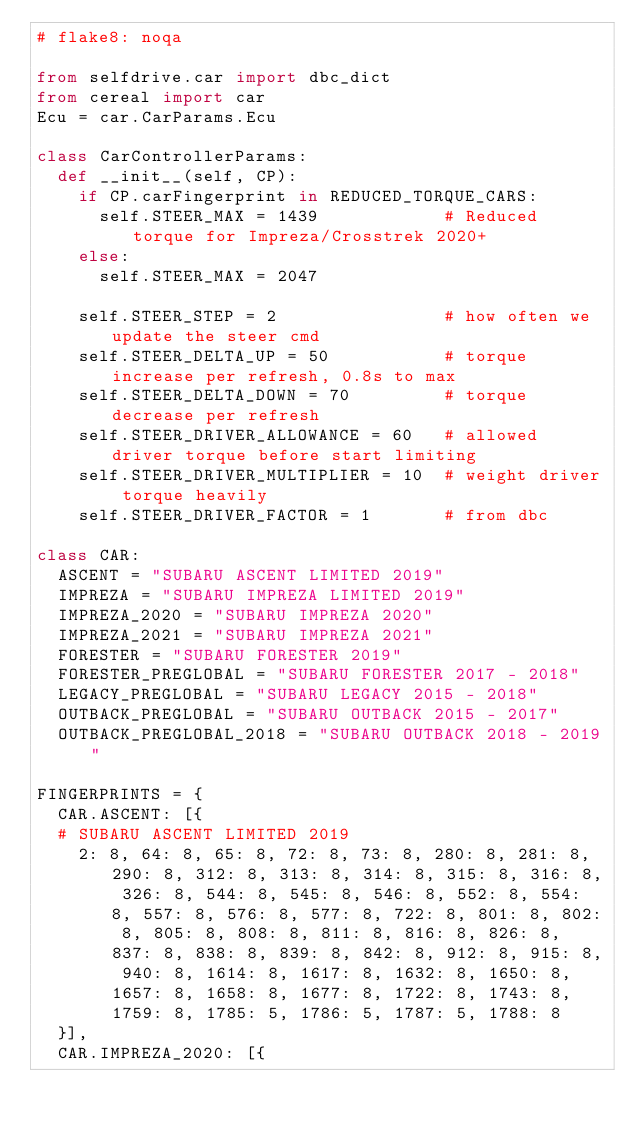Convert code to text. <code><loc_0><loc_0><loc_500><loc_500><_Python_># flake8: noqa

from selfdrive.car import dbc_dict
from cereal import car
Ecu = car.CarParams.Ecu

class CarControllerParams:
  def __init__(self, CP):
    if CP.carFingerprint in REDUCED_TORQUE_CARS:
      self.STEER_MAX = 1439            # Reduced torque for Impreza/Crosstrek 2020+
    else:
      self.STEER_MAX = 2047

    self.STEER_STEP = 2                # how often we update the steer cmd
    self.STEER_DELTA_UP = 50           # torque increase per refresh, 0.8s to max
    self.STEER_DELTA_DOWN = 70         # torque decrease per refresh
    self.STEER_DRIVER_ALLOWANCE = 60   # allowed driver torque before start limiting
    self.STEER_DRIVER_MULTIPLIER = 10  # weight driver torque heavily
    self.STEER_DRIVER_FACTOR = 1       # from dbc

class CAR:
  ASCENT = "SUBARU ASCENT LIMITED 2019"
  IMPREZA = "SUBARU IMPREZA LIMITED 2019"
  IMPREZA_2020 = "SUBARU IMPREZA 2020"
  IMPREZA_2021 = "SUBARU IMPREZA 2021"
  FORESTER = "SUBARU FORESTER 2019"
  FORESTER_PREGLOBAL = "SUBARU FORESTER 2017 - 2018"
  LEGACY_PREGLOBAL = "SUBARU LEGACY 2015 - 2018"
  OUTBACK_PREGLOBAL = "SUBARU OUTBACK 2015 - 2017"
  OUTBACK_PREGLOBAL_2018 = "SUBARU OUTBACK 2018 - 2019"

FINGERPRINTS = {
  CAR.ASCENT: [{
  # SUBARU ASCENT LIMITED 2019
    2: 8, 64: 8, 65: 8, 72: 8, 73: 8, 280: 8, 281: 8, 290: 8, 312: 8, 313: 8, 314: 8, 315: 8, 316: 8, 326: 8, 544: 8, 545: 8, 546: 8, 552: 8, 554: 8, 557: 8, 576: 8, 577: 8, 722: 8, 801: 8, 802: 8, 805: 8, 808: 8, 811: 8, 816: 8, 826: 8, 837: 8, 838: 8, 839: 8, 842: 8, 912: 8, 915: 8, 940: 8, 1614: 8, 1617: 8, 1632: 8, 1650: 8, 1657: 8, 1658: 8, 1677: 8, 1722: 8, 1743: 8, 1759: 8, 1785: 5, 1786: 5, 1787: 5, 1788: 8
  }],
  CAR.IMPREZA_2020: [{</code> 